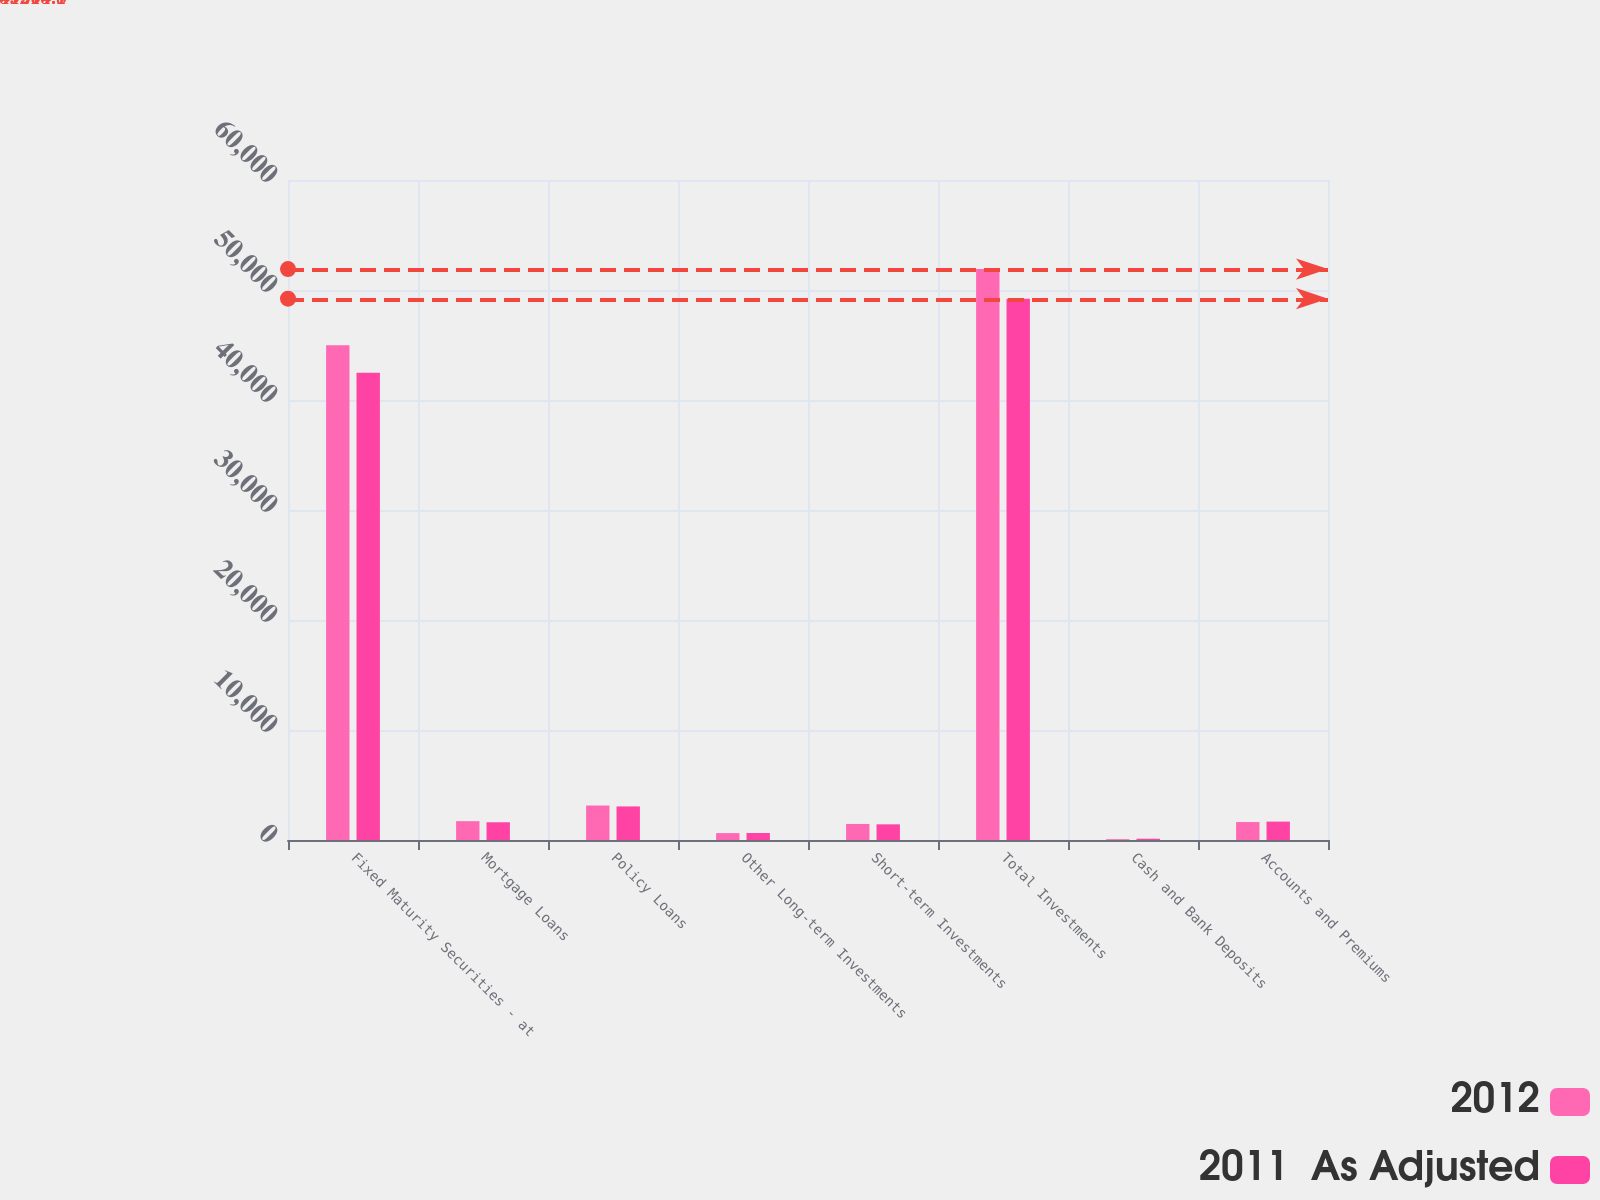Convert chart. <chart><loc_0><loc_0><loc_500><loc_500><stacked_bar_chart><ecel><fcel>Fixed Maturity Securities - at<fcel>Mortgage Loans<fcel>Policy Loans<fcel>Other Long-term Investments<fcel>Short-term Investments<fcel>Total Investments<fcel>Cash and Bank Deposits<fcel>Accounts and Premiums<nl><fcel>2012<fcel>44973<fcel>1712.7<fcel>3133.8<fcel>625<fcel>1460.3<fcel>51904.8<fcel>77.3<fcel>1632.6<nl><fcel>2011  As Adjusted<fcel>42486.7<fcel>1612.3<fcel>3051.4<fcel>639.2<fcel>1423.5<fcel>49213.1<fcel>116.6<fcel>1672.2<nl></chart> 